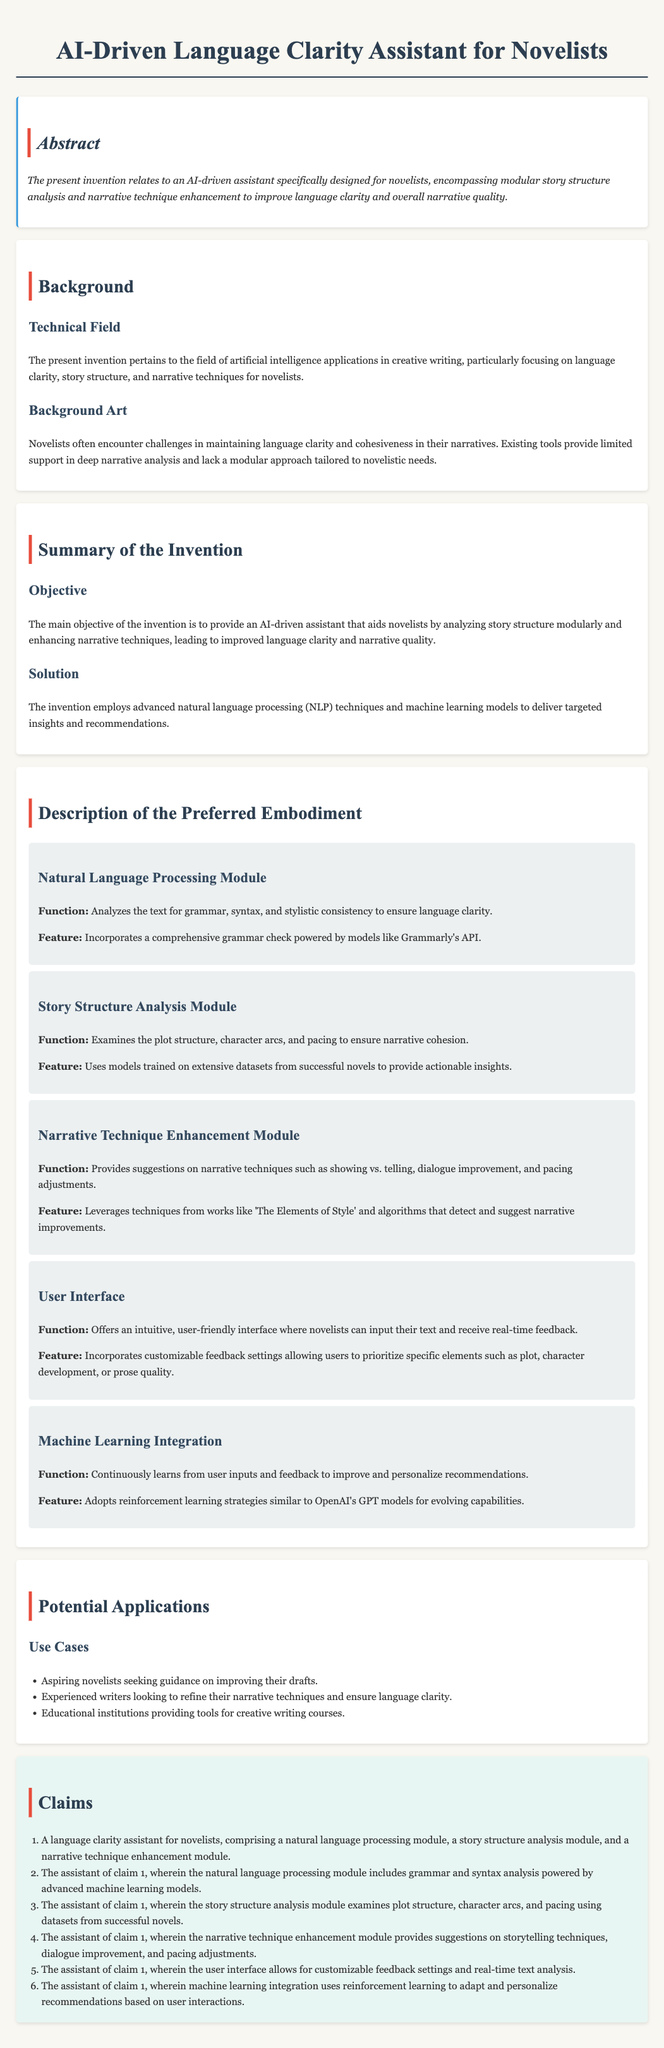What is the title of the invention? The title is found at the top of the document, emphasizing the focus of the invention.
Answer: AI-Driven Language Clarity Assistant for Novelists What is the primary function of the Natural Language Processing Module? The function is described in the section about the module, detailing what it analyzes.
Answer: Analyzes the text for grammar, syntax, and stylistic consistency How many modules are detailed in the Description of the Preferred Embodiment? The number of modules can be counted from the sections listed under the preferred embodiment description.
Answer: Five What technique does the Machine Learning Integration use for improving recommendations? The technique is mentioned in relation to the learning strategy employed by the assistant.
Answer: Reinforcement learning Who are the intended users of the AI-driven assistant? The intended users are grouped in the potential applications section identifying various categories of users.
Answer: Aspiring novelists, experienced writers, educational institutions What is the main objective of the invention? The objective is stated in the Summary of the Invention, summarizing what the invention aims to achieve.
Answer: To provide an AI-driven assistant that aids novelists Which module uses datasets from successful novels? The module that incorporates these datasets is specified within its described function in the document.
Answer: Story Structure Analysis Module What does the user interface feature in terms of feedback? The feature discussed in relation to user interaction highlights a specific capability of the interface.
Answer: Customizable feedback settings 